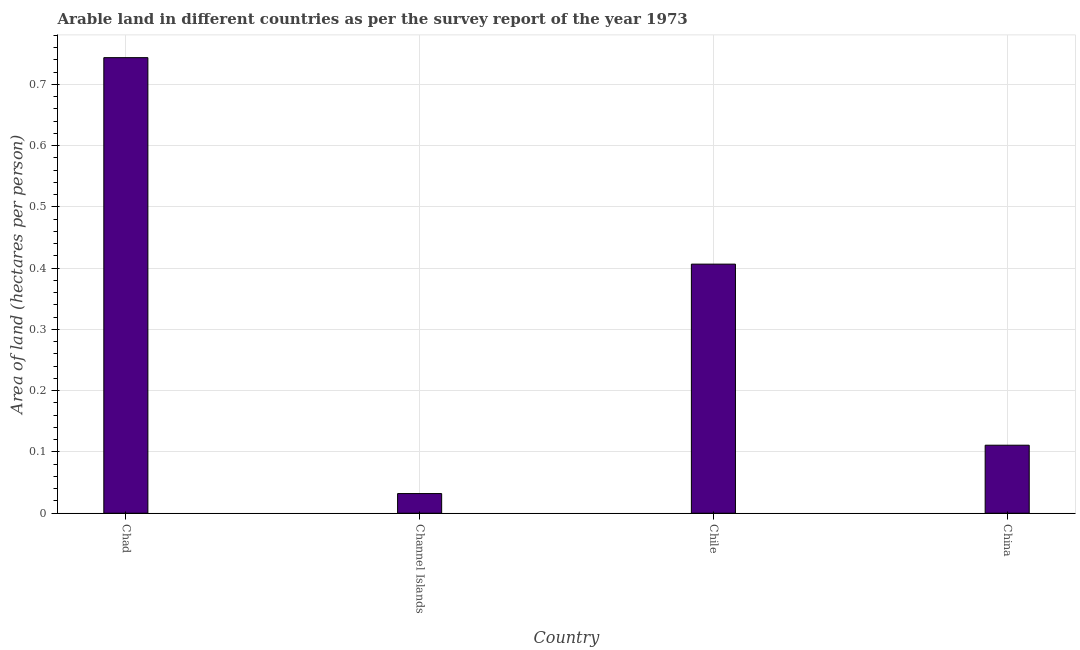Does the graph contain any zero values?
Your response must be concise. No. What is the title of the graph?
Provide a short and direct response. Arable land in different countries as per the survey report of the year 1973. What is the label or title of the Y-axis?
Keep it short and to the point. Area of land (hectares per person). What is the area of arable land in China?
Make the answer very short. 0.11. Across all countries, what is the maximum area of arable land?
Your response must be concise. 0.74. Across all countries, what is the minimum area of arable land?
Ensure brevity in your answer.  0.03. In which country was the area of arable land maximum?
Your response must be concise. Chad. In which country was the area of arable land minimum?
Give a very brief answer. Channel Islands. What is the sum of the area of arable land?
Make the answer very short. 1.29. What is the difference between the area of arable land in Chile and China?
Offer a very short reply. 0.3. What is the average area of arable land per country?
Offer a terse response. 0.32. What is the median area of arable land?
Your response must be concise. 0.26. In how many countries, is the area of arable land greater than 0.32 hectares per person?
Your answer should be compact. 2. What is the ratio of the area of arable land in Chad to that in Channel Islands?
Provide a short and direct response. 23.19. Is the area of arable land in Channel Islands less than that in China?
Provide a succinct answer. Yes. Is the difference between the area of arable land in Chile and China greater than the difference between any two countries?
Your answer should be compact. No. What is the difference between the highest and the second highest area of arable land?
Provide a succinct answer. 0.34. Is the sum of the area of arable land in Channel Islands and Chile greater than the maximum area of arable land across all countries?
Your answer should be compact. No. What is the difference between the highest and the lowest area of arable land?
Make the answer very short. 0.71. Are all the bars in the graph horizontal?
Your response must be concise. No. Are the values on the major ticks of Y-axis written in scientific E-notation?
Provide a short and direct response. No. What is the Area of land (hectares per person) of Chad?
Provide a short and direct response. 0.74. What is the Area of land (hectares per person) in Channel Islands?
Ensure brevity in your answer.  0.03. What is the Area of land (hectares per person) of Chile?
Keep it short and to the point. 0.41. What is the Area of land (hectares per person) in China?
Ensure brevity in your answer.  0.11. What is the difference between the Area of land (hectares per person) in Chad and Channel Islands?
Offer a very short reply. 0.71. What is the difference between the Area of land (hectares per person) in Chad and Chile?
Make the answer very short. 0.34. What is the difference between the Area of land (hectares per person) in Chad and China?
Keep it short and to the point. 0.63. What is the difference between the Area of land (hectares per person) in Channel Islands and Chile?
Your answer should be very brief. -0.37. What is the difference between the Area of land (hectares per person) in Channel Islands and China?
Your answer should be very brief. -0.08. What is the difference between the Area of land (hectares per person) in Chile and China?
Your answer should be compact. 0.3. What is the ratio of the Area of land (hectares per person) in Chad to that in Channel Islands?
Ensure brevity in your answer.  23.19. What is the ratio of the Area of land (hectares per person) in Chad to that in Chile?
Give a very brief answer. 1.83. What is the ratio of the Area of land (hectares per person) in Chad to that in China?
Give a very brief answer. 6.7. What is the ratio of the Area of land (hectares per person) in Channel Islands to that in Chile?
Give a very brief answer. 0.08. What is the ratio of the Area of land (hectares per person) in Channel Islands to that in China?
Your answer should be compact. 0.29. What is the ratio of the Area of land (hectares per person) in Chile to that in China?
Your answer should be very brief. 3.66. 